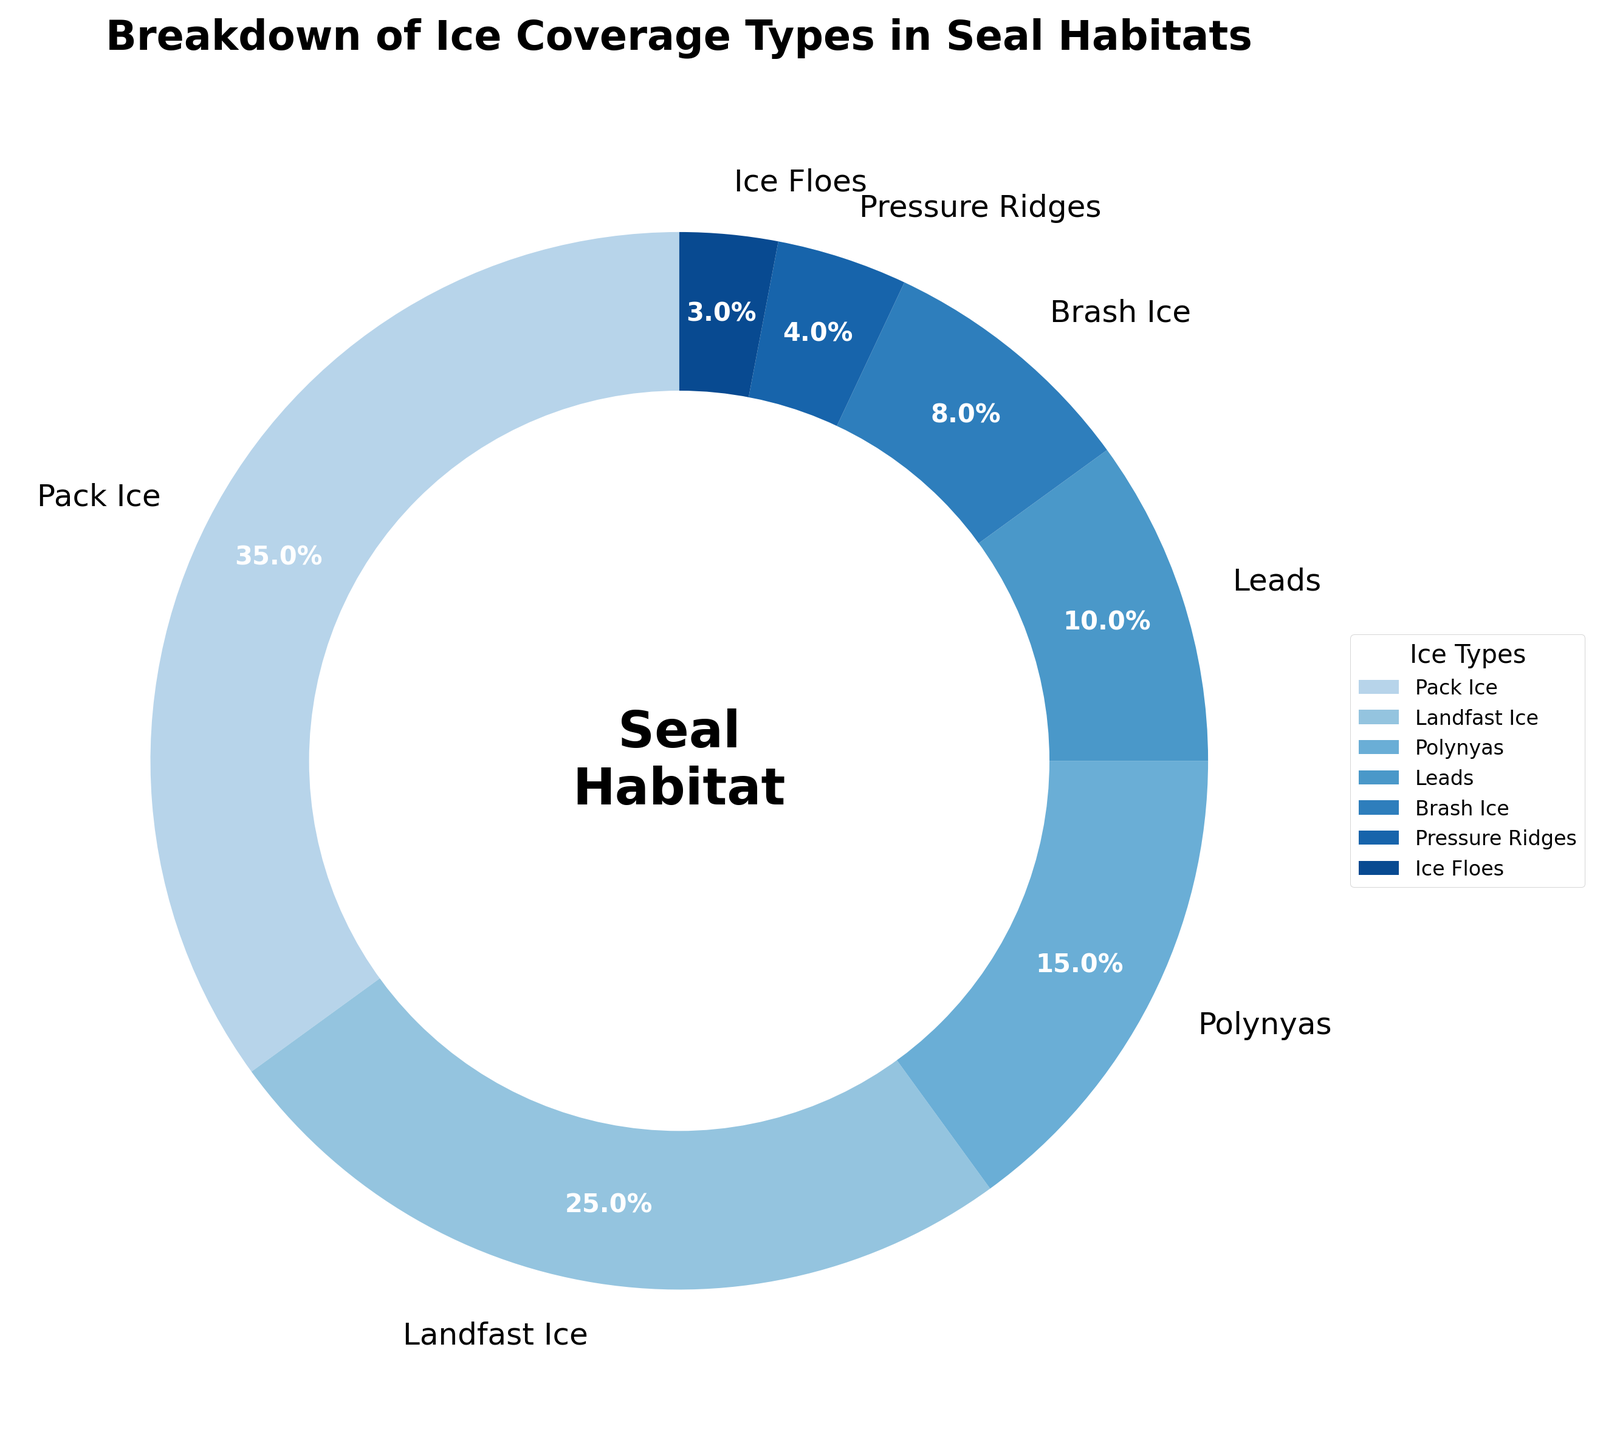What percentage of the seal habitat is covered by Pack Ice and Landfast Ice combined? To find the combined percentage of Pack Ice and Landfast Ice, add their individual percentages: 35% + 25% = 60%
Answer: 60% Which ice type covers the smallest percentage of the seal habitat? The smallest percentage is represented by the smallest wedge in the pie chart. This wedge corresponds to Ice Floes with 3%.
Answer: Ice Floes How much more ice coverage does Pack Ice have compared to Leads? To find how much more ice coverage Pack Ice has compared to Leads, subtract the percentage of Leads from the percentage of Pack Ice: 35% - 10% = 25%
Answer: 25% What two ice types together cover less than 10% of the seal habitat? Identify the ice types with percentages adding up to less than 10%. Ice Floes (3%) and Pressure Ridges (4%) combined cover 7%, which is less than 10%.
Answer: Ice Floes and Pressure Ridges Rank the ice types from the largest to the smallest percentage of coverage. To rank the ice types, list them from the largest percentage to the smallest: Pack Ice (35%), Landfast Ice (25%), Polynyas (15%), Leads (10%), Brash Ice (8%), Pressure Ridges (4%), Ice Floes (3%).
Answer: Pack Ice, Landfast Ice, Polynyas, Leads, Brash Ice, Pressure Ridges, Ice Floes What is the difference in percentage coverage between Polynyas and Brash Ice? Subtract the percentage of Brash Ice from the percentage of Polynyas: 15% - 8% = 7%
Answer: 7% If the total percentage of other categories (excluding Pack Ice and Landfast Ice) increased by 5%, which category would take precedence in attention following Pack Ice and Landfast Ice? Current percentages of other categories are: Polynyas (15%), Leads (10%), Brash Ice (8%), Pressure Ridges (4%), Ice Floes (3%). After a 5% increase, Polynyas would rise to 15% + 5% = 20%, which is the largest among these.
Answer: Polynyas Which is larger: the sum of the percentage coverage of Polynyas and Leads or the coverage of Landfast Ice alone? Calculate the sum of the percentages of Polynyas and Leads: 15% + 10% = 25%. Compare it to the percentage of Landfast Ice, which is also 25%. They are equal.
Answer: Equal What percentage of the habitat is covered by ice types other than Pack Ice? Subtract the percentage of Pack Ice from 100% to find the percentage covered by other ice types: 100% - 35% = 65%
Answer: 65% If we consider only Pack Ice, Landfast Ice, and Polynyas, what fraction of the habitat do they collectively cover? Add the percentages of Pack Ice, Landfast Ice, and Polynyas: 35% + 25% + 15% = 75%. The fraction represented is 75/100, which simplifies to 3/4.
Answer: 3/4 